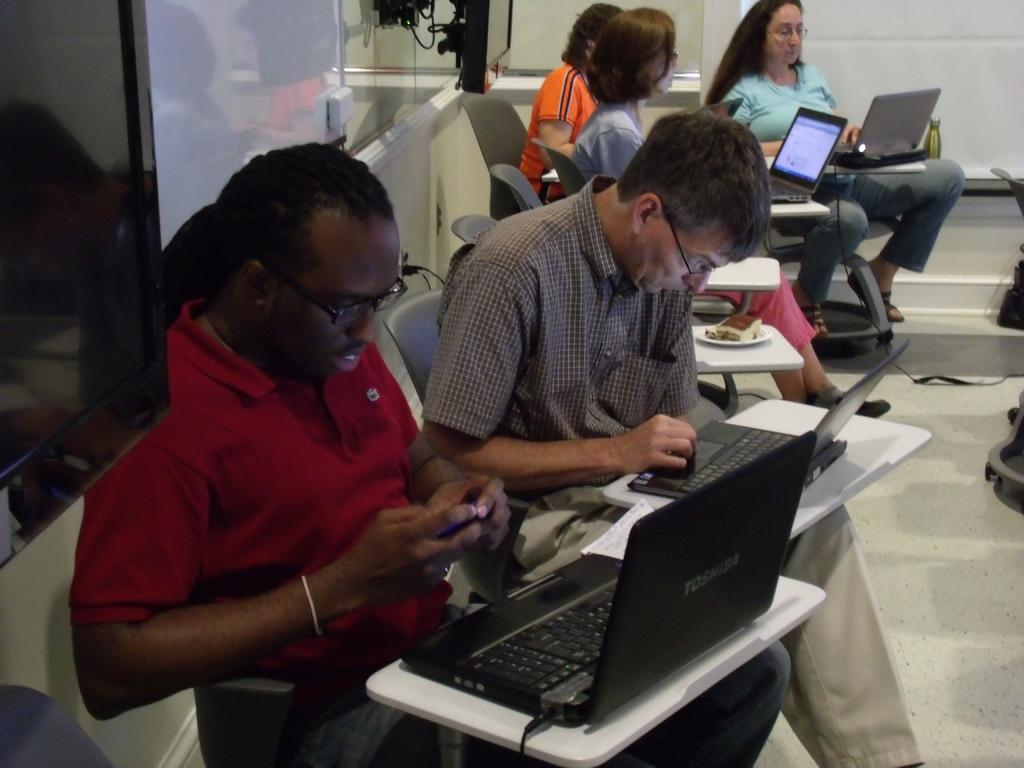What are the persons in the image doing? The persons in the image are sitting on the table with laptops. What can be seen on the left side of the image? There are televisions on the left side of the image. What is visible in the background of the image? There is a board and a wall in the background of the image. What type of payment is being made in the image? There is no indication of any payment being made in the image. Can you see a sheet on the table in the image? There is no sheet visible on the table in the image. 